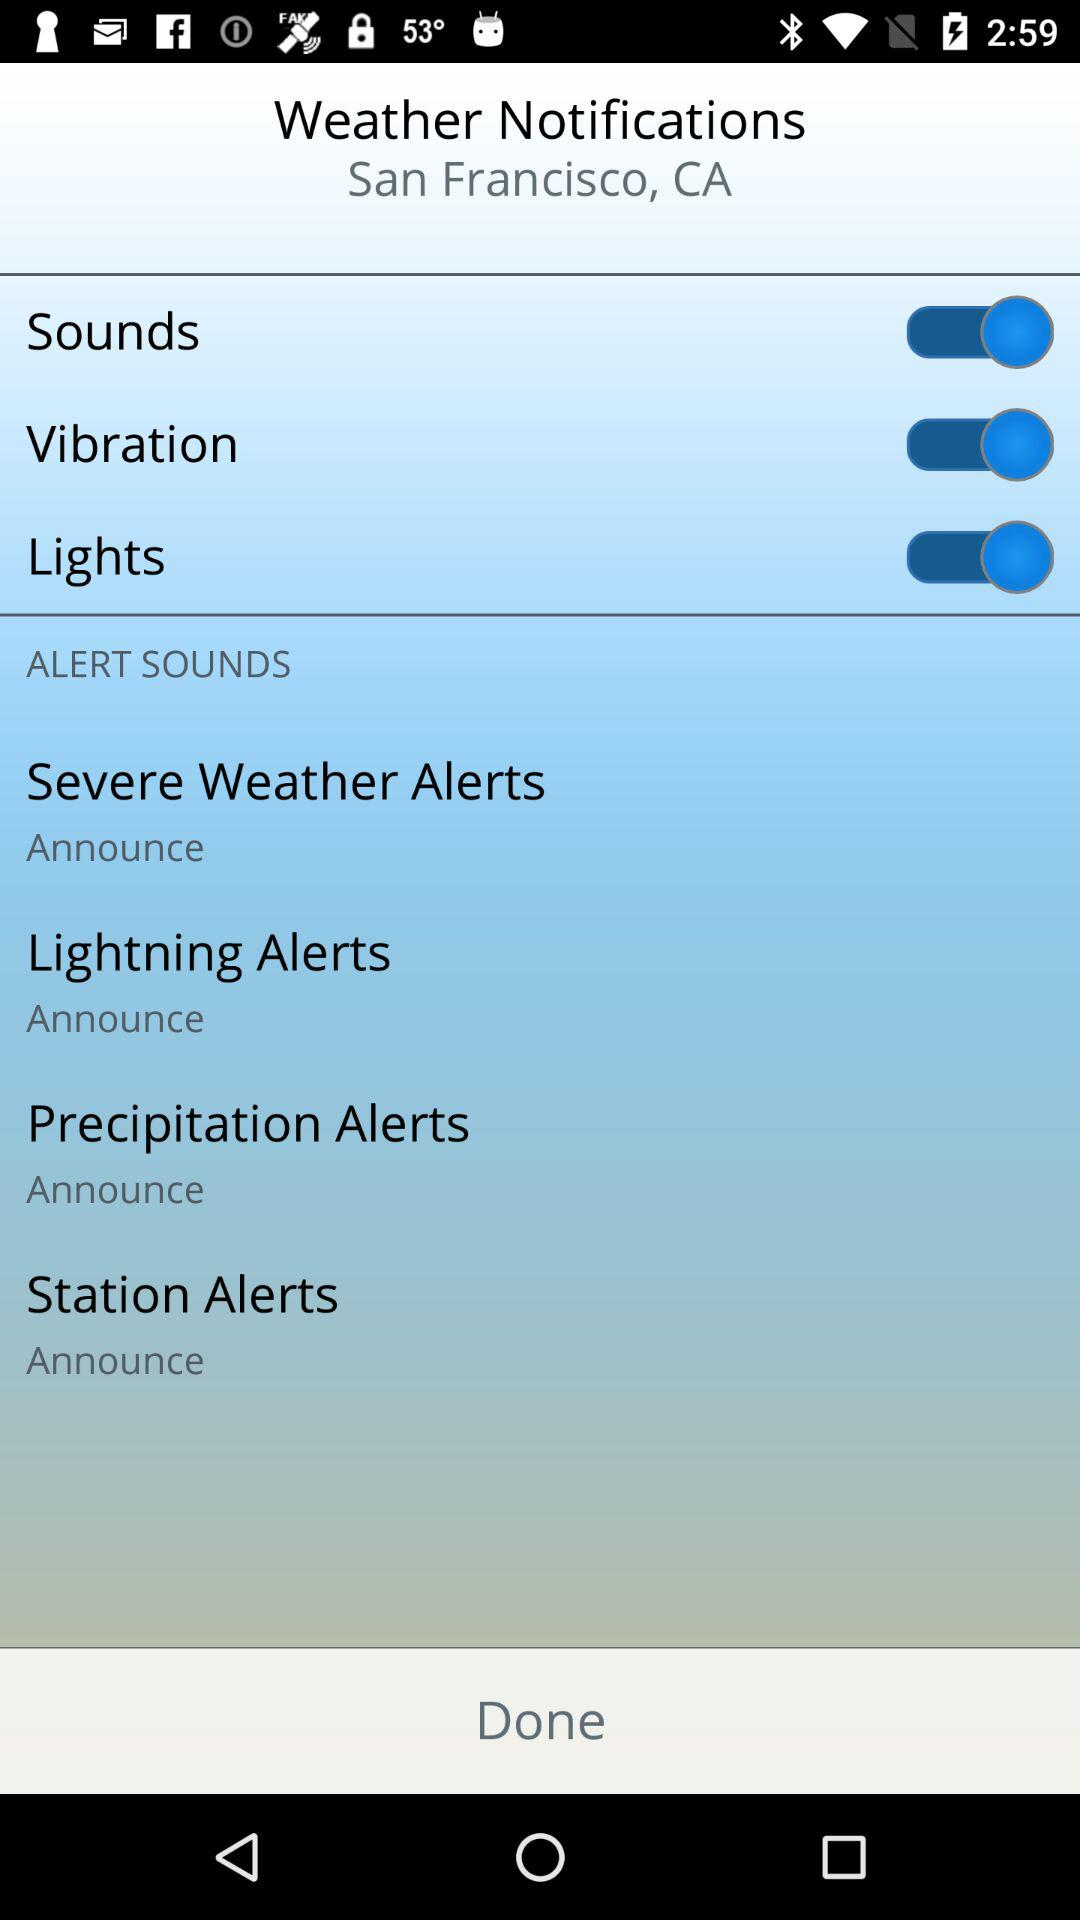What is the status of "Sounds"? The status of "Sounds" is "on". 